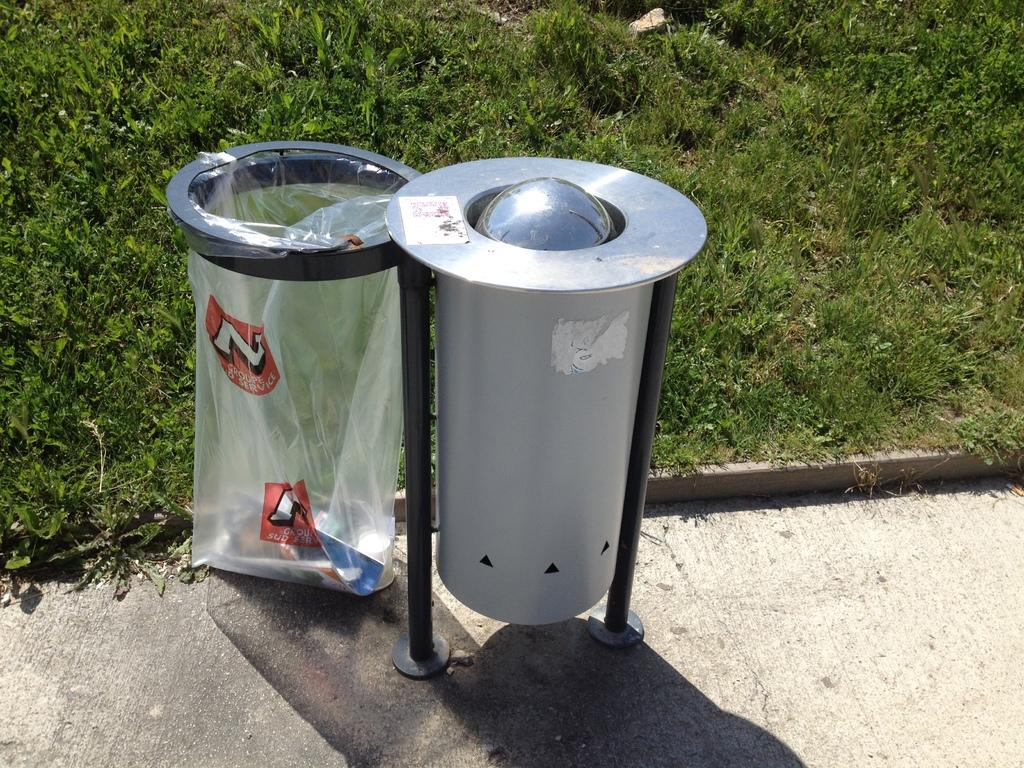<image>
Provide a brief description of the given image. A transparent trash bag has a letter N and the word service on it. 